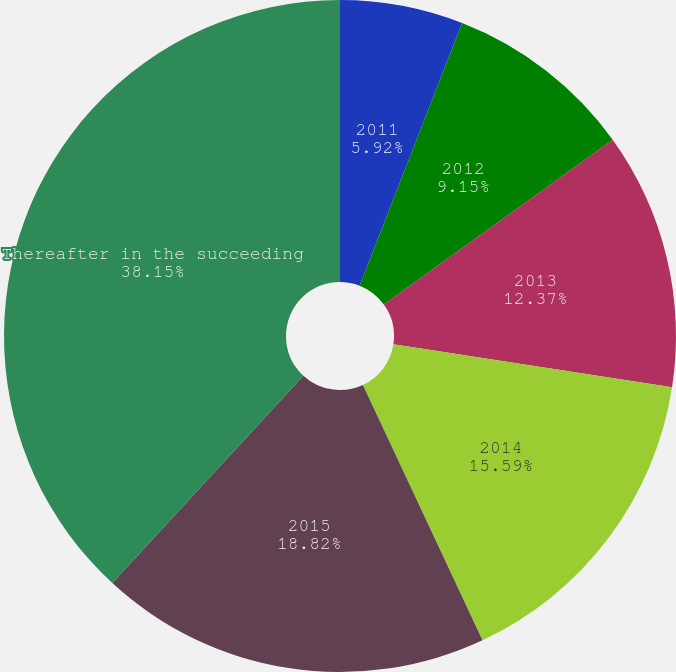Convert chart to OTSL. <chart><loc_0><loc_0><loc_500><loc_500><pie_chart><fcel>2011<fcel>2012<fcel>2013<fcel>2014<fcel>2015<fcel>Thereafter in the succeeding<nl><fcel>5.92%<fcel>9.15%<fcel>12.37%<fcel>15.59%<fcel>18.82%<fcel>38.15%<nl></chart> 